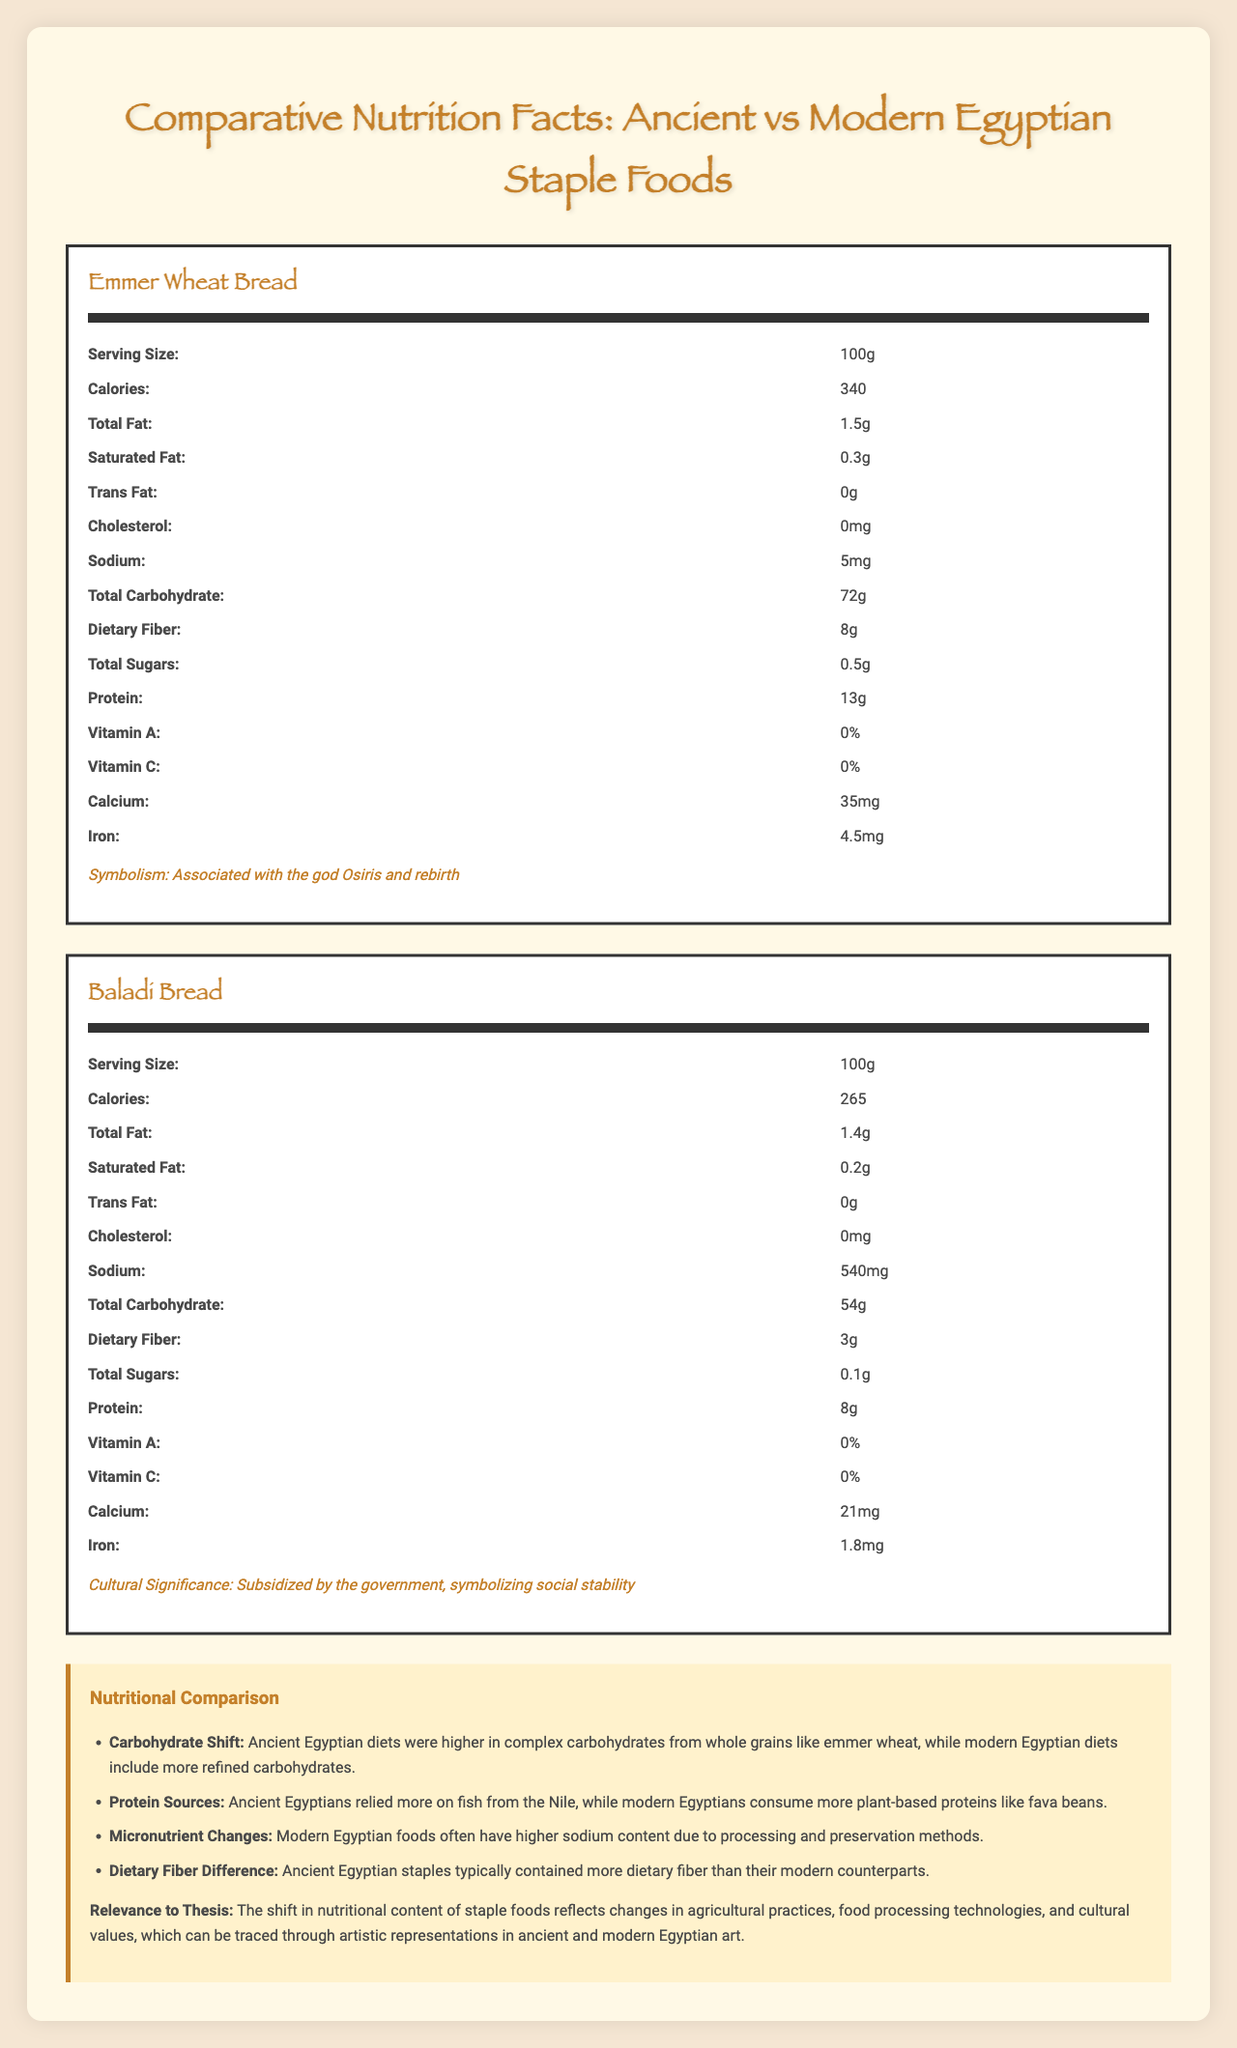What is the serving size of Emmer Wheat Bread? The serving size is explicitly listed in the nutrition facts for Emmer Wheat Bread.
Answer: 100g Which ancient Egyptian staple food mentioned has a higher calorie content? Emmer Wheat Bread has 340 calories, while Nile Tilapia has 96 calories per serving.
Answer: Emmer Wheat Bread How much sodium is in Baladi Bread? The sodium content for Baladi Bread is listed as 540mg.
Answer: 540mg What is the carbohydrate content of Ful Medames compared to Emmer Wheat Bread? The carbohydrate content is directly listed under the nutritional facts for each food.
Answer: Ful Medames: 22g, Emmer Wheat Bread: 72g Does Nile Tilapia contain dietary fiber? The document lists 0g for dietary fiber content in Nile Tilapia.
Answer: No Summarize the nutritional differences between ancient and modern Egyptian staple foods. The document compares the nutritional content of both periods and highlights changes in carbohydrate types and sodium levels, emphasizing shifts due to agricultural and processing practices.
Answer: Ancient staple foods tend to have higher dietary fiber and complex carbohydrates, whereas modern staples have more refined carbohydrates and higher sodium. Which modern Egyptian staple food has the highest protein content? 
A. Baladi Bread
B. Ful Medames Ful Medames contains 9g of protein, whereas Baladi Bread has only 8g of protein.
Answer: B. Ful Medames What is one symbolic association of Nile Tilapia in ancient Egypt? 
A. Associated with wealth
B. Linked to rebirth
C. Associated with fertility The document states that Nile Tilapia is symbolically linked to the goddess Hathor and fertility.
Answer: C. Associated with fertility Is the vitamin C content in modern Egyptian staple foods typically higher than in ancient ones? Ful Medames has 1mg of vitamin C, while none of the ancient staples have any vitamin C content listed.
Answer: Yes Identify one trend in the nutritional comparison section. This trend is mentioned explicitly in the nutritional comparison section.
Answer: Modern Egyptian diets include more refined carbohydrates. Compare the calcium content of Emmer Wheat Bread and Baladi Bread. The calcium content for both types of bread is listed in their respective nutritional facts sections.
Answer: Emmer Wheat Bread: 35mg, Baladi Bread: 21mg What role does Baladi Bread play in modern Egyptian society? The document mentions that Baladi Bread is subsidized by the government, symbolizing social stability.
Answer: Symbolizes social stability Does Nile Tilapia or Ful Medames have a higher total fat content? Ful Medames has 2.5g of total fat compared to 1.7g in Nile Tilapia.
Answer: Ful Medames How is the shift in dietary fiber content between ancient and modern Egyptian staple foods relevant to your thesis? The shift in dietary fiber content, as explained in the document, indicates broader changes in agricultural practices, food processing technologies, and cultural values, which are relevant to the study of changes in Egyptian art and society.
Answer: Reflects changes in agricultural practices and cultural values. What is the exact vitamin A content in Emmer Wheat Bread? The vitamin A content for Emmer Wheat Bread is provided as 0%, but without a specific numerical value.
Answer: Cannot be determined Describe the primary focus of the document. It outlines nutritional compositions, symbolic and cultural significances, and includes a section on the nutritional comparison, providing insights on shifts between the two periods.
Answer: The document compares the nutritional facts of ancient and modern Egyptian staple foods, analyzing shifts in dietary content and their cultural significance. 